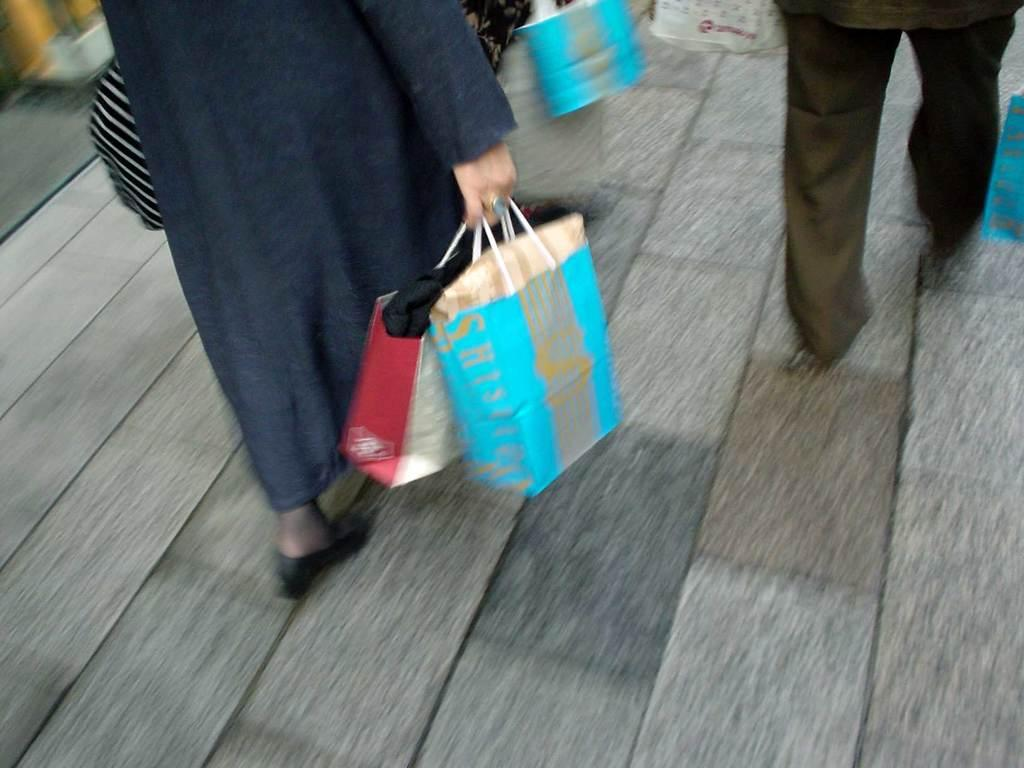Who is the main subject in the image? There is a woman in the image. What is the woman doing in the image? The woman is walking on a footpath. What is the woman carrying in her hand? The woman is carrying two bags in her hand. Are there any other people in the image? Yes, there are other people walking in the image. What type of van can be seen parked on the street in the image? There is no van or street present in the image; it features a woman walking on a footpath. 